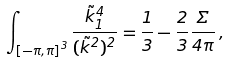<formula> <loc_0><loc_0><loc_500><loc_500>\int _ { \left [ - \pi , \pi \right ] ^ { 3 } } \frac { \tilde { k } _ { 1 } ^ { 4 } } { ( \tilde { k } ^ { 2 } ) ^ { 2 } } = \frac { 1 } { 3 } - \frac { 2 } { 3 } \frac { \Sigma } { 4 \pi } \, ,</formula> 